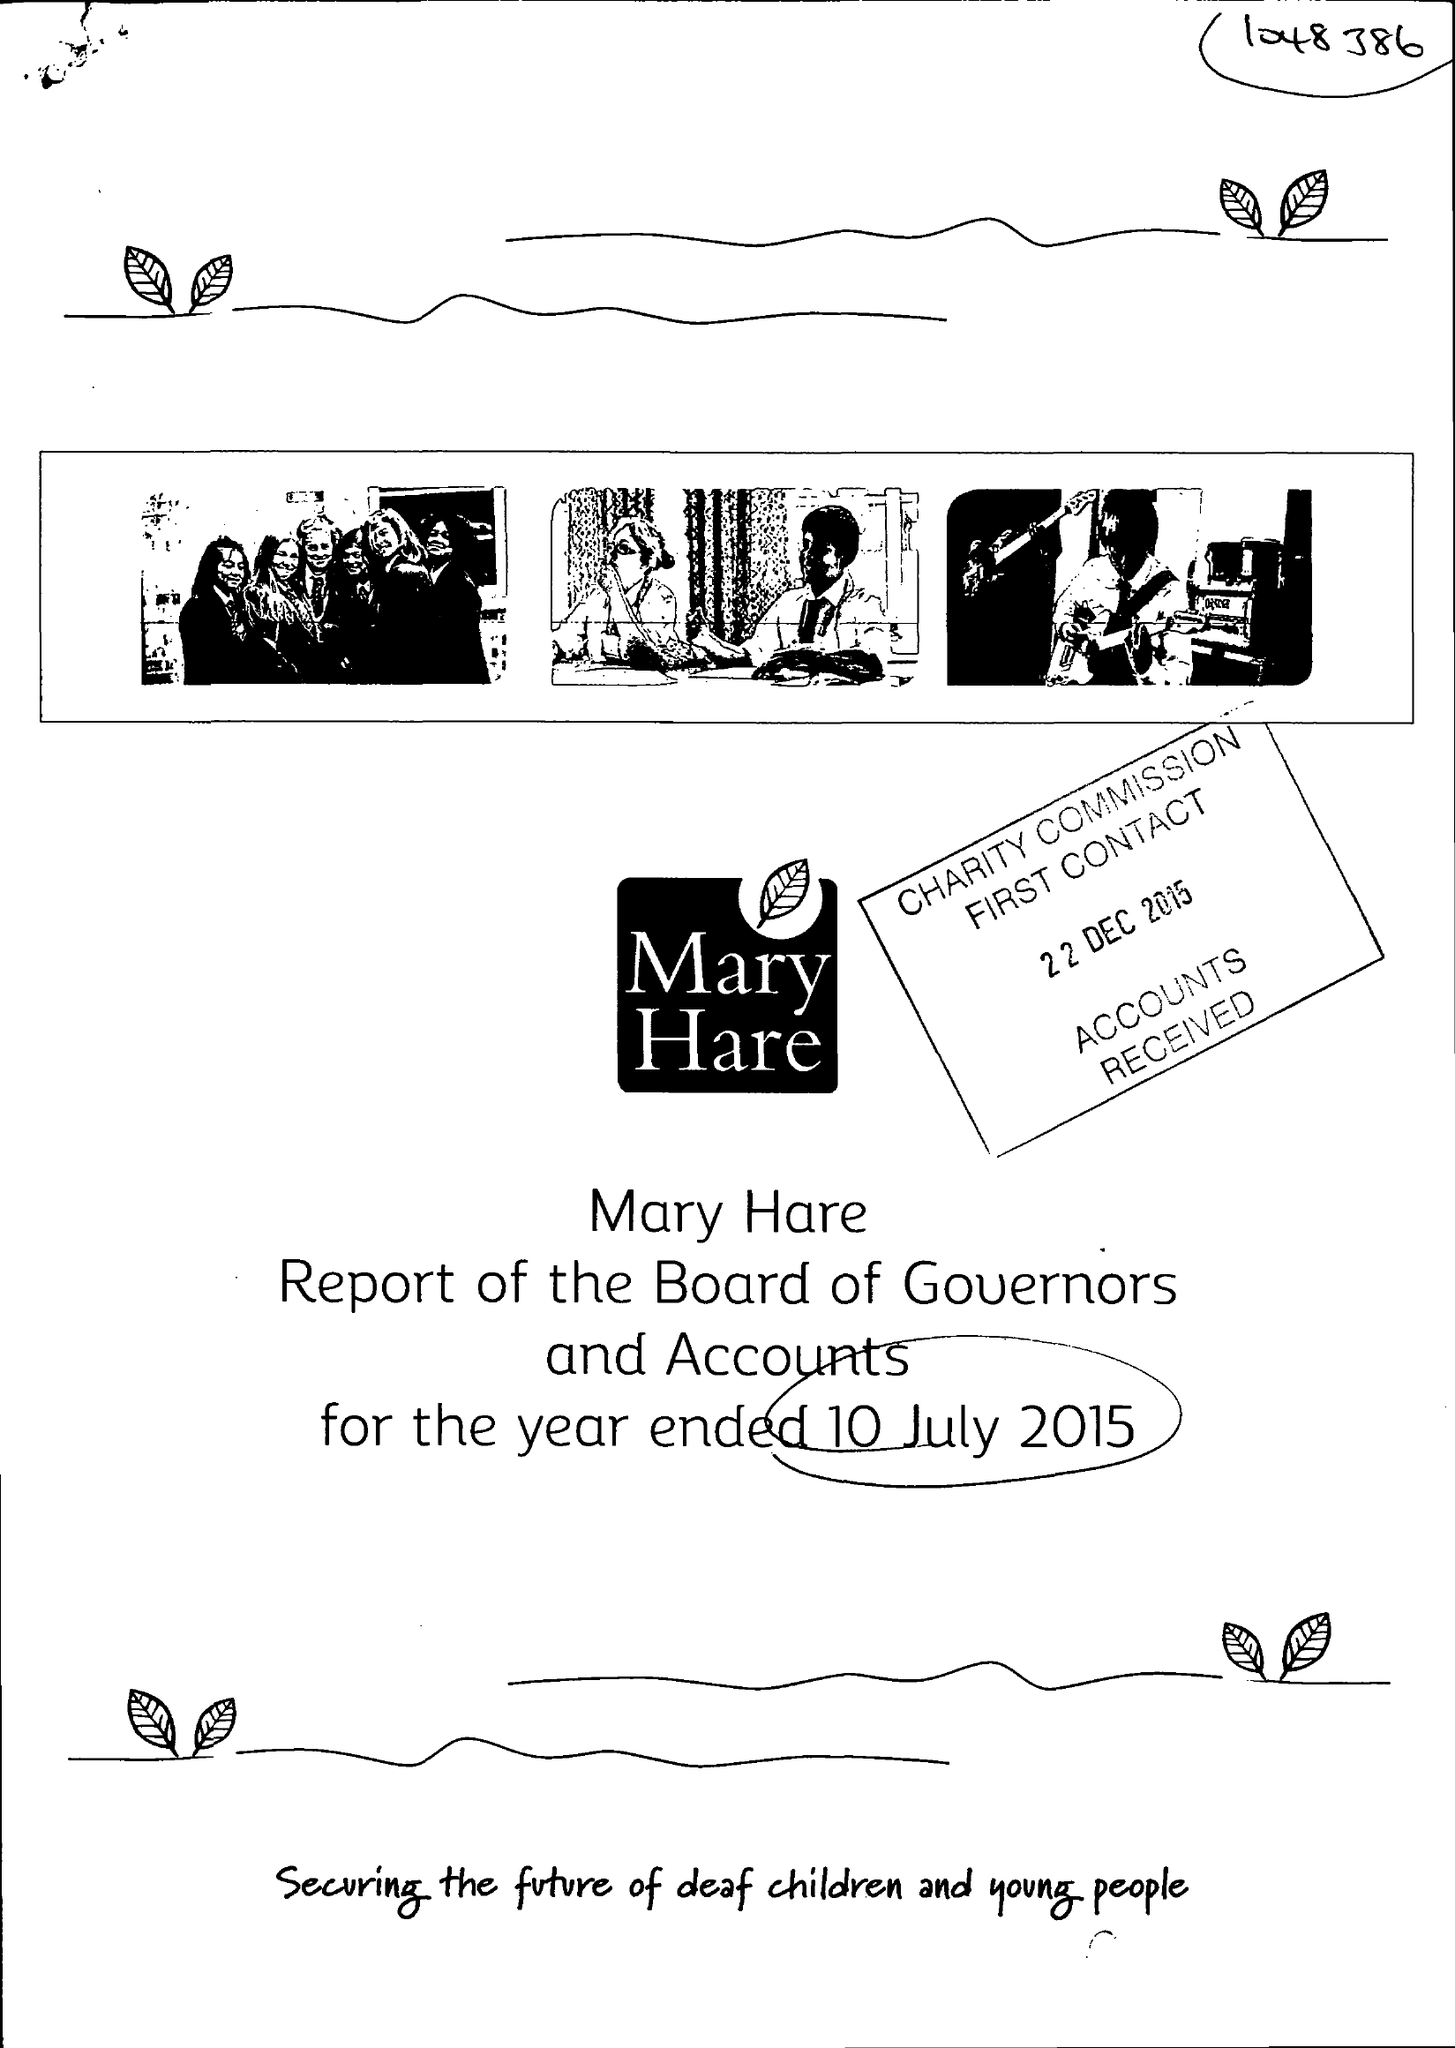What is the value for the address__post_town?
Answer the question using a single word or phrase. NEWBURY 